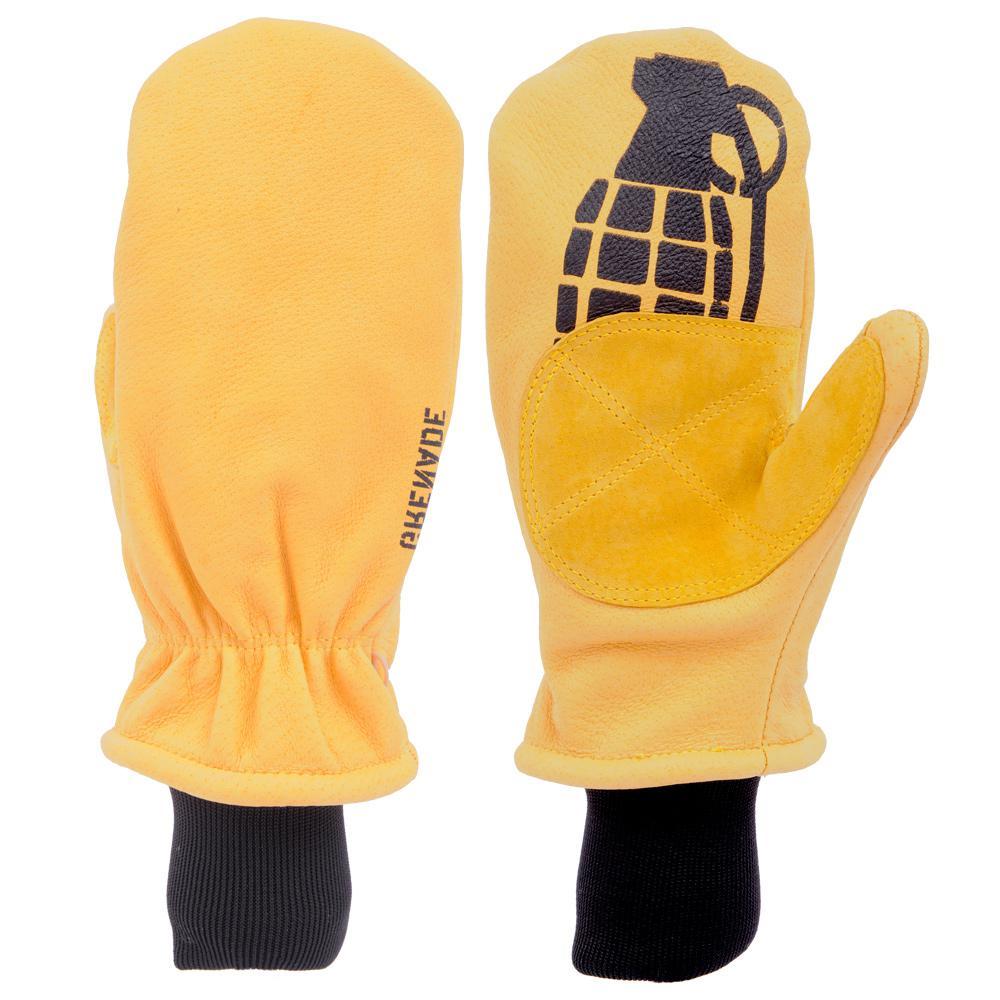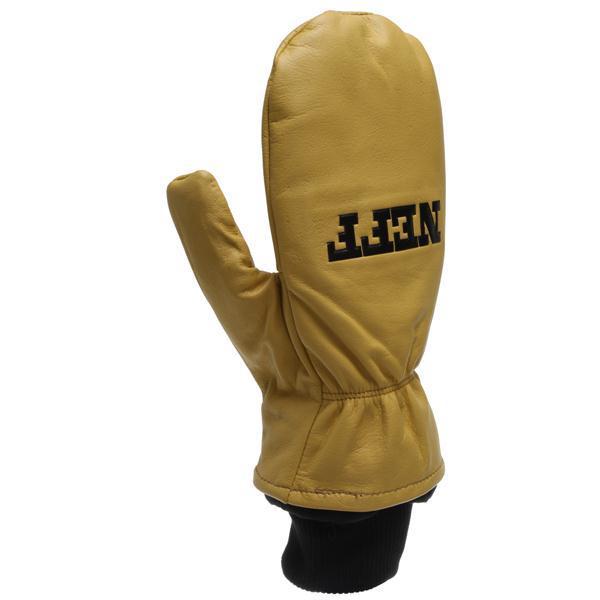The first image is the image on the left, the second image is the image on the right. Considering the images on both sides, is "Each image shows the front and reverse sides of a pair of mittens, with the cuff opening at the bottom." valid? Answer yes or no. No. The first image is the image on the left, the second image is the image on the right. Evaluate the accuracy of this statement regarding the images: "Two pairs of mittens are shown in front and back views, but with only one pair is one thumb section extended to the side.". Is it true? Answer yes or no. No. 